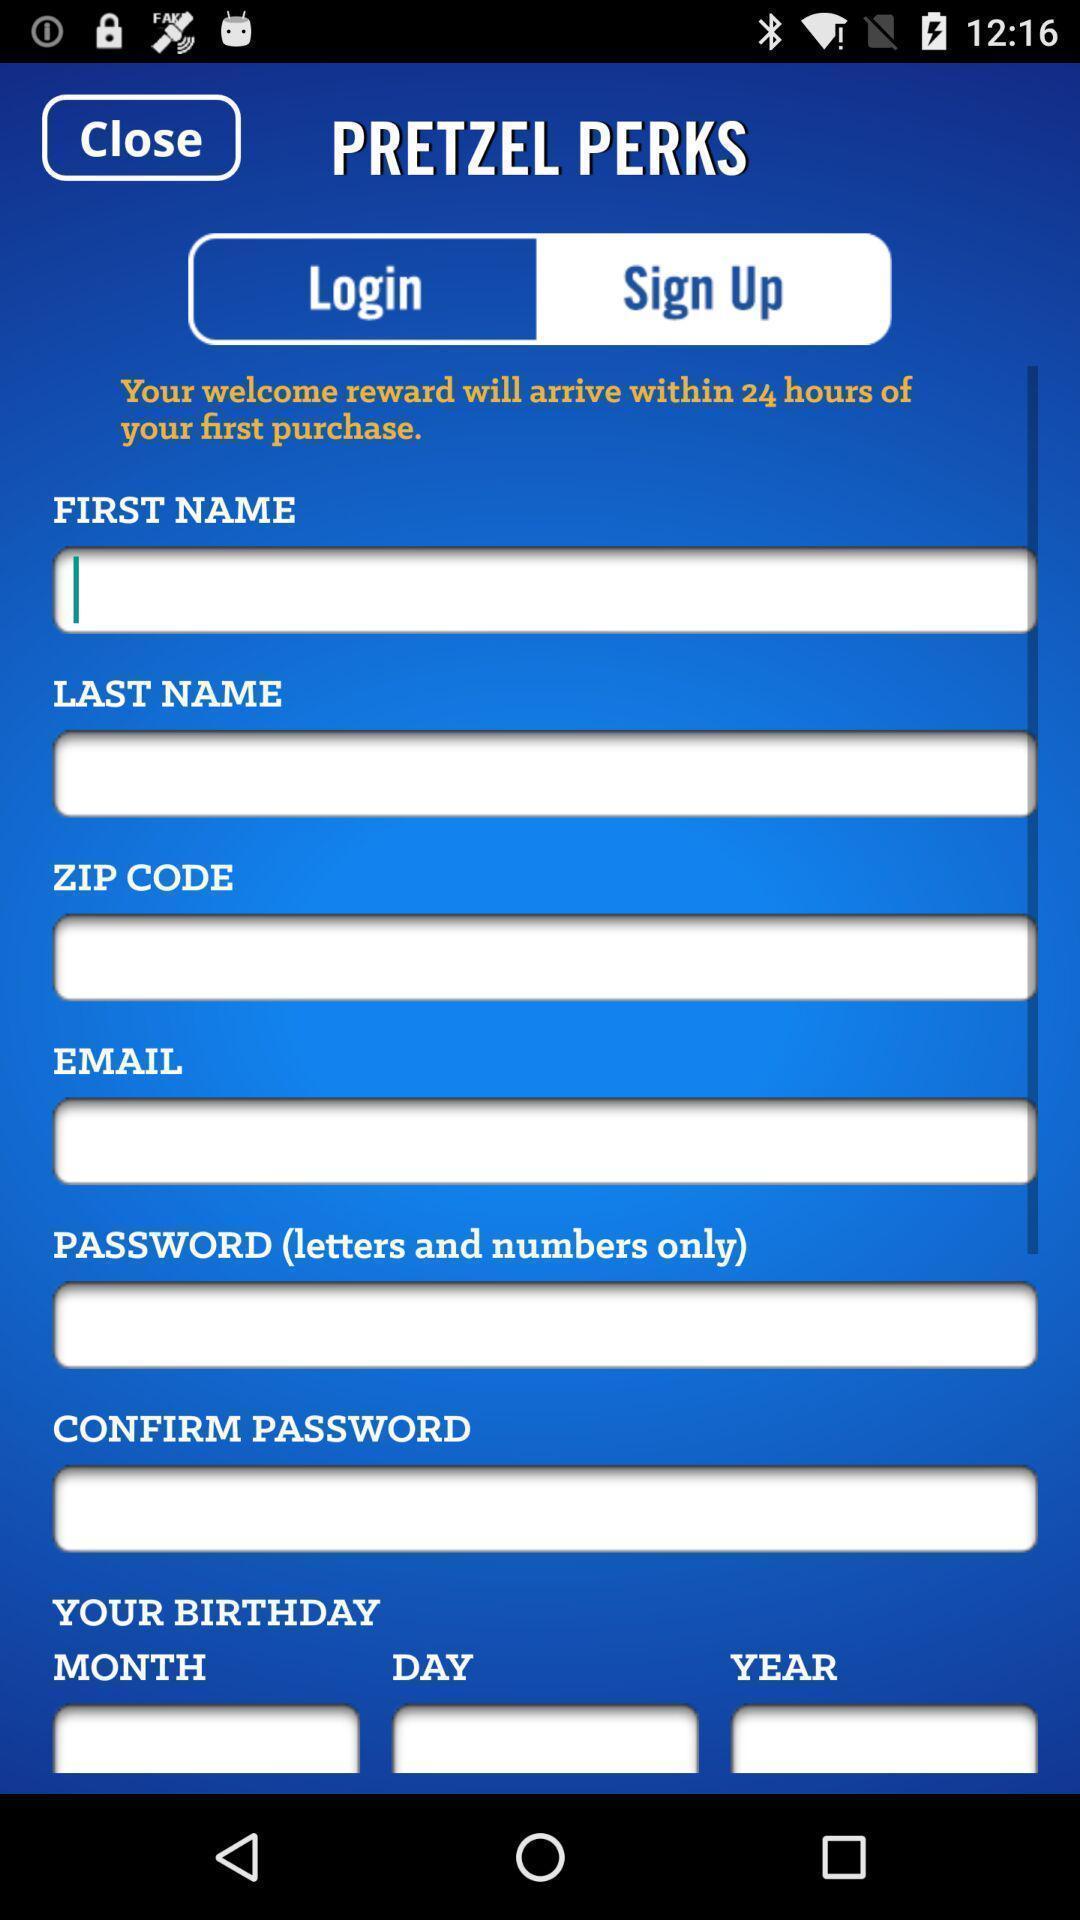Summarize the main components in this picture. Sign up page. 